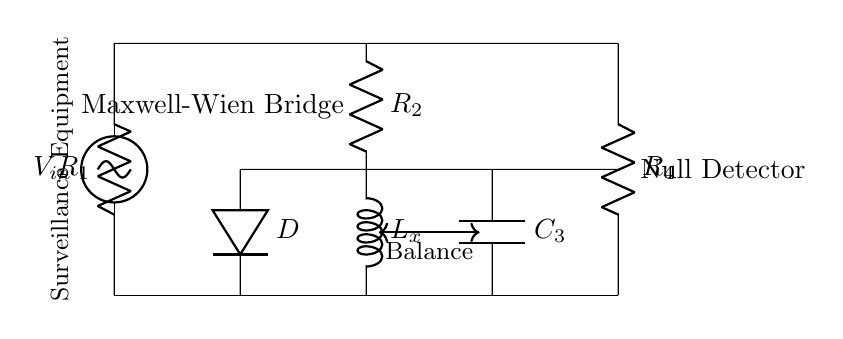What is the type of bridge shown in the circuit? The circuit is labeled as a Maxwell-Wien Bridge, indicated by the label in the diagram. This type of bridge is specifically used for measuring inductance.
Answer: Maxwell-Wien Bridge What is the component labeled L_x used for? The component labeled L_x represents an inductor, which in this context is used to determine its inductance within the surveillance equipment application.
Answer: Inductor How many resistors are in the circuit? The circuit contains four resistors, labeled as R_1, R_2, R_4, and AD. Each resistor is marked in the diagram, showing their positions in the bridge.
Answer: Four Which component is used as a null detector? The null detector is indicated as being at the end of the bridge with the label "Null Detector," which is responsible for measuring the balance condition of the bridge.
Answer: Null Detector What is the configuration of the inductor and capacitor in relation to other components? The inductor L_x and capacitor C_3 are set in parallel with other components in the circuit, forming part of the bridge where the balance is achieved for measuring inductance.
Answer: Parallel What does the term "Balance" refer to in the circuit? The term "Balance" refers to the condition when the potential difference across the meter (null detector) is zero, indicating that the bridge is balanced and allows for accurate measurement of inductance.
Answer: Zero Voltage What is the purpose of the input voltage labeled V_in? V_in is the input voltage provided to the Maxwell-Wien Bridge to initiate the measurement process, allowing the bridge to compare the impedance of the known and unknown components.
Answer: Measurement Input 